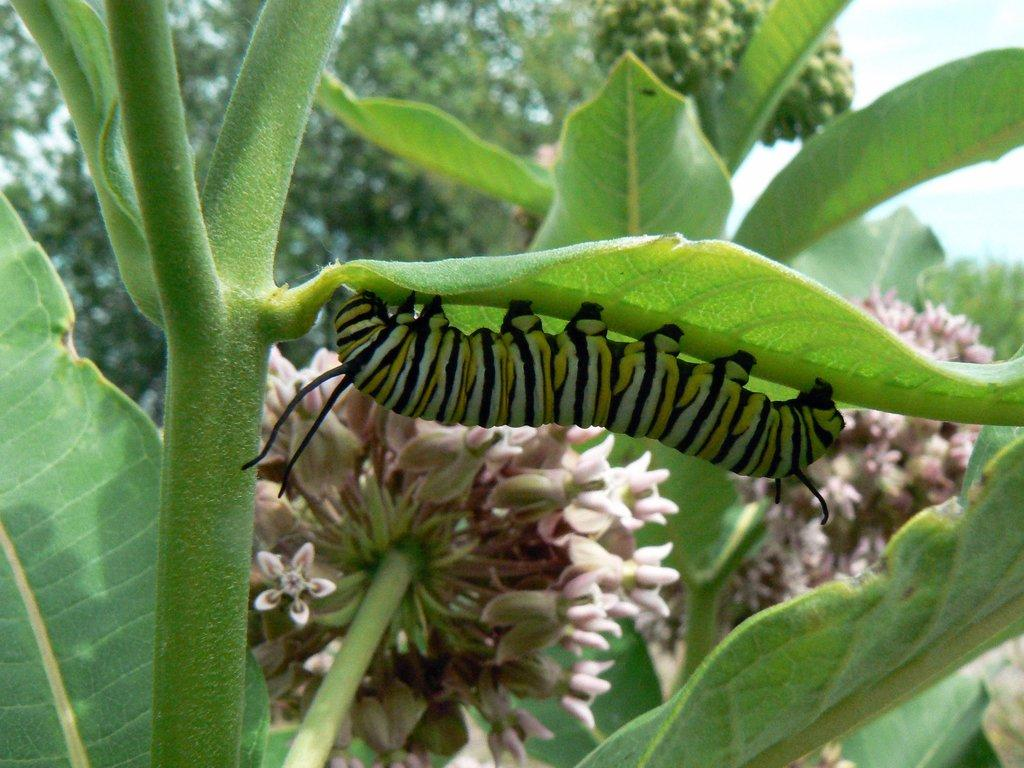What is the main subject in the front of the image? There is a caterpillar in the front of the image. What type of plants can be seen in the image? There are flowers, stems, and leaves in the image. How would you describe the background of the image? The background of the image is blurred. What can be seen in the far background of the image? There is a tree and the sky visible in the background. What group of people is the caterpillar reading with in the image? There are no people present in the image, and the caterpillar is not reading. 